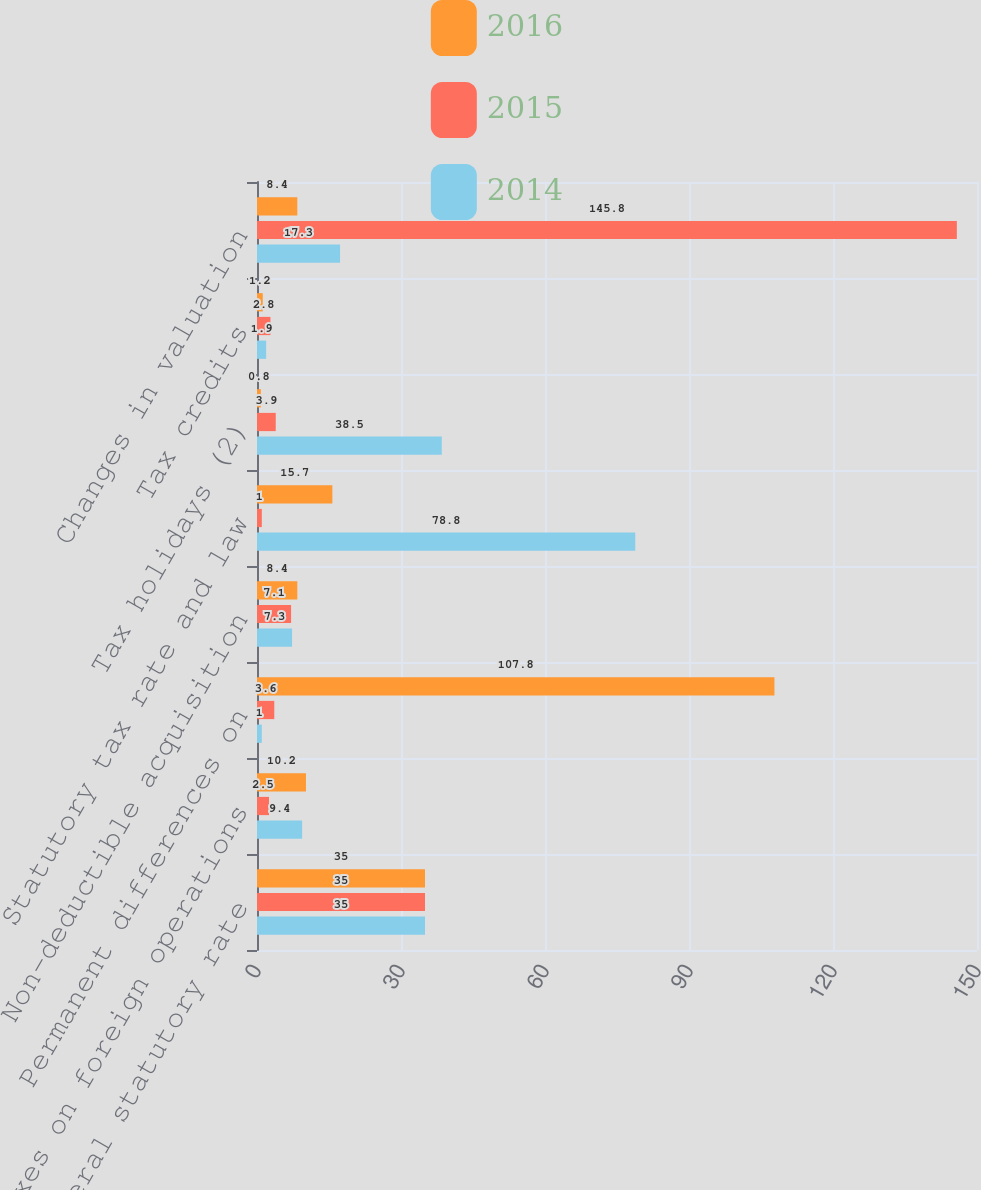<chart> <loc_0><loc_0><loc_500><loc_500><stacked_bar_chart><ecel><fcel>US federal statutory rate<fcel>Taxes on foreign operations<fcel>Permanent differences on<fcel>Non-deductible acquisition<fcel>Statutory tax rate and law<fcel>Tax holidays (2)<fcel>Tax credits<fcel>Changes in valuation<nl><fcel>2016<fcel>35<fcel>10.2<fcel>107.8<fcel>8.4<fcel>15.7<fcel>0.8<fcel>1.2<fcel>8.4<nl><fcel>2015<fcel>35<fcel>2.5<fcel>3.6<fcel>7.1<fcel>1<fcel>3.9<fcel>2.8<fcel>145.8<nl><fcel>2014<fcel>35<fcel>9.4<fcel>1<fcel>7.3<fcel>78.8<fcel>38.5<fcel>1.9<fcel>17.3<nl></chart> 